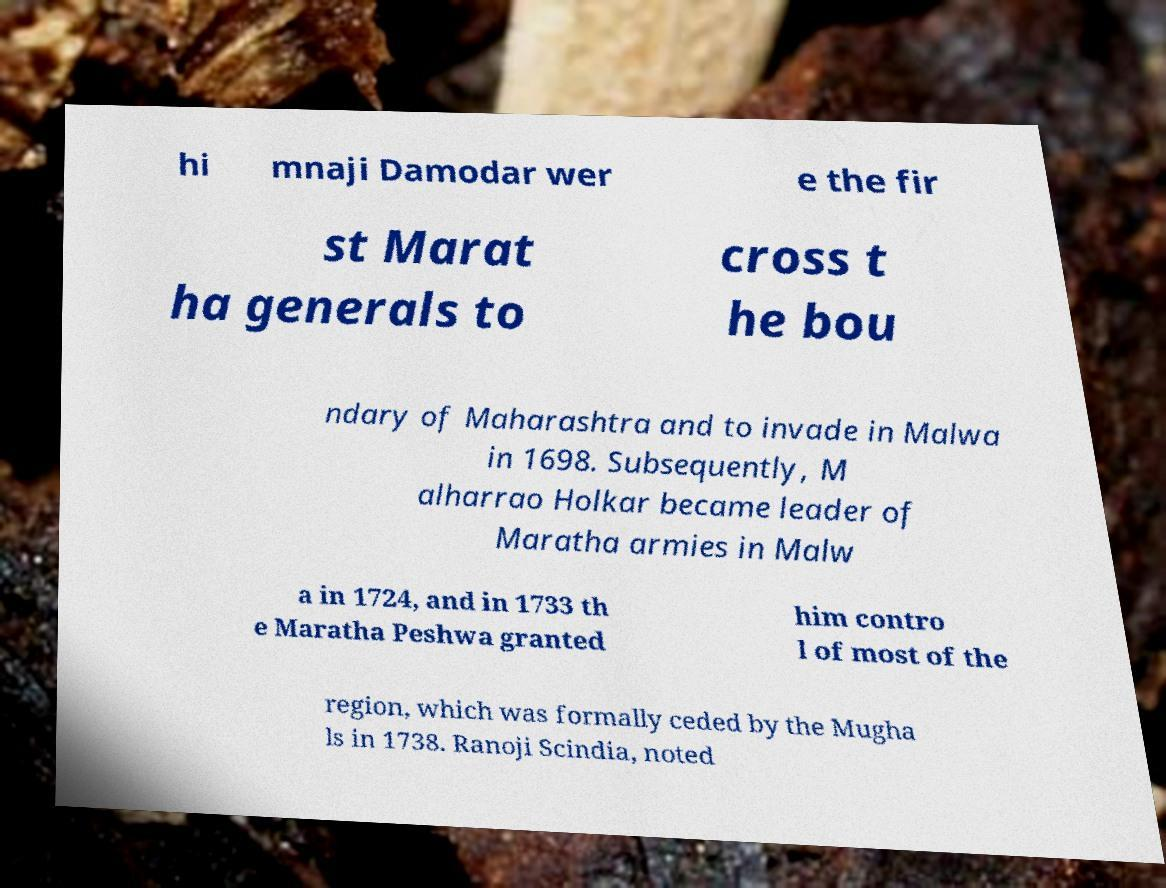Could you assist in decoding the text presented in this image and type it out clearly? hi mnaji Damodar wer e the fir st Marat ha generals to cross t he bou ndary of Maharashtra and to invade in Malwa in 1698. Subsequently, M alharrao Holkar became leader of Maratha armies in Malw a in 1724, and in 1733 th e Maratha Peshwa granted him contro l of most of the region, which was formally ceded by the Mugha ls in 1738. Ranoji Scindia, noted 